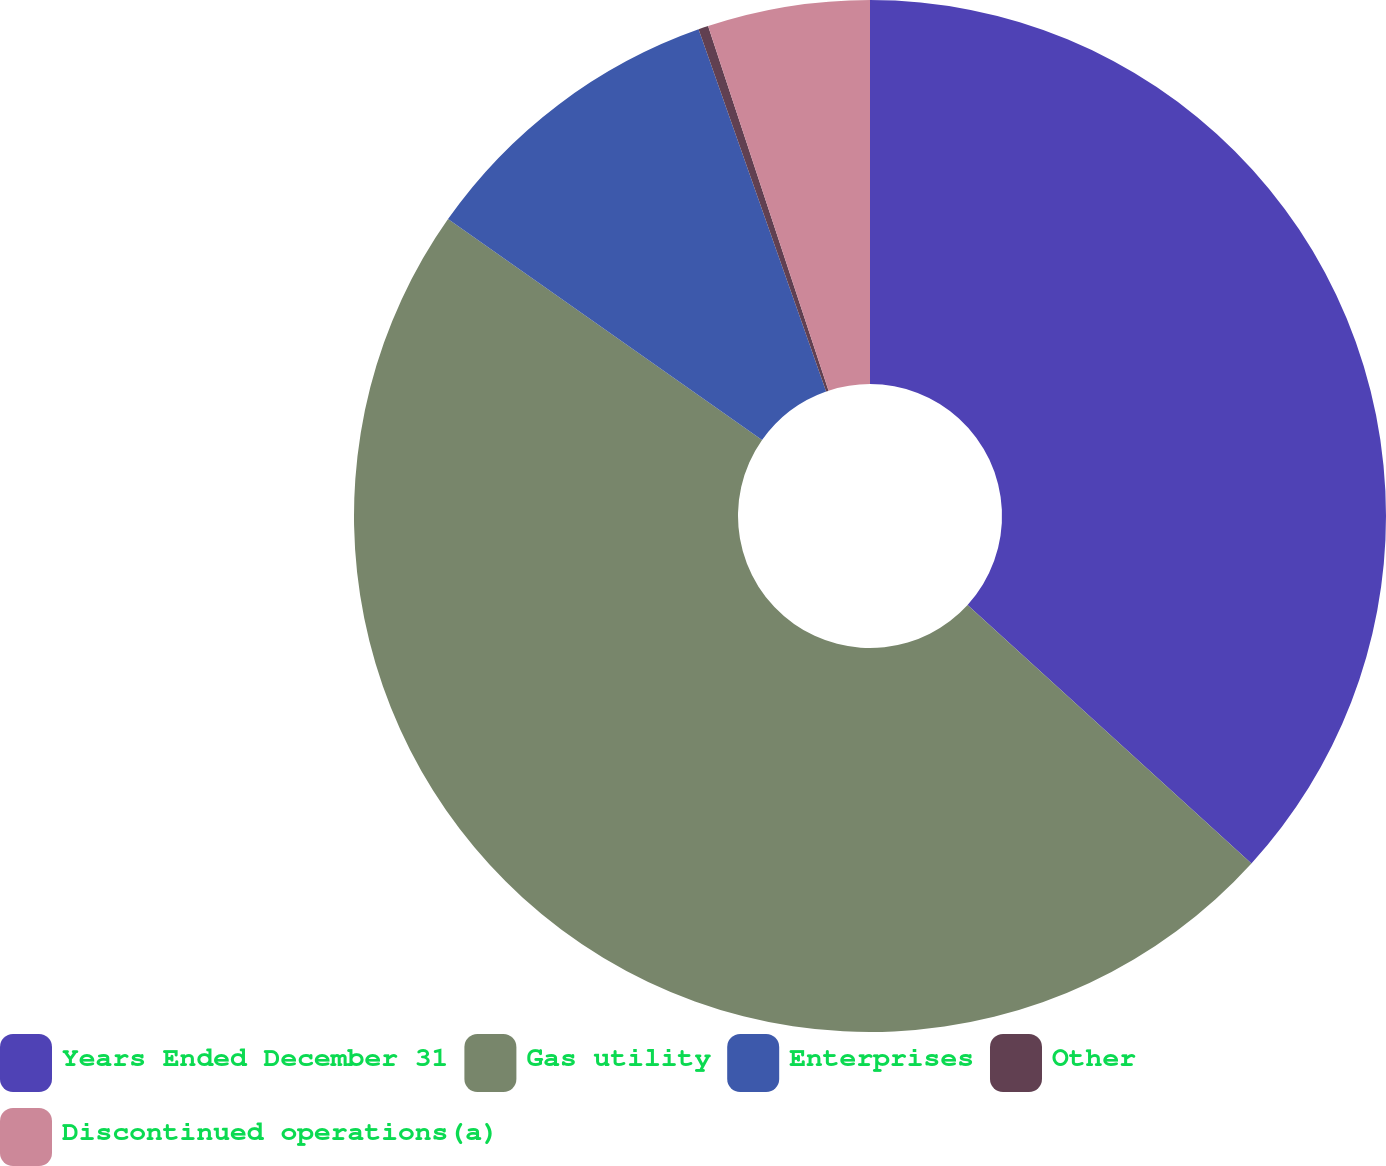Convert chart to OTSL. <chart><loc_0><loc_0><loc_500><loc_500><pie_chart><fcel>Years Ended December 31<fcel>Gas utility<fcel>Enterprises<fcel>Other<fcel>Discontinued operations(a)<nl><fcel>36.76%<fcel>48.0%<fcel>9.85%<fcel>0.31%<fcel>5.08%<nl></chart> 